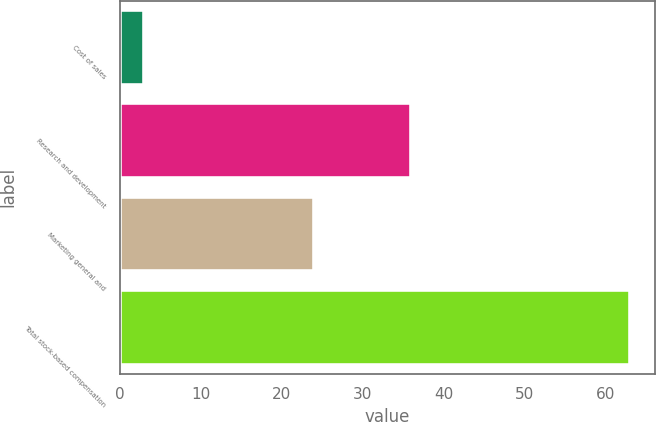Convert chart. <chart><loc_0><loc_0><loc_500><loc_500><bar_chart><fcel>Cost of sales<fcel>Research and development<fcel>Marketing general and<fcel>Total stock-based compensation<nl><fcel>3<fcel>36<fcel>24<fcel>63<nl></chart> 